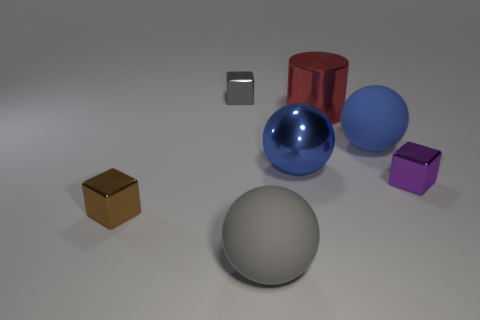The small metal object that is both left of the red shiny cylinder and in front of the cylinder is what color?
Provide a succinct answer. Brown. Are there any purple blocks left of the metallic block on the right side of the red shiny object?
Ensure brevity in your answer.  No. Are there an equal number of large blue shiny balls that are right of the big red thing and big red metal cubes?
Your answer should be very brief. Yes. There is a small purple thing in front of the metallic block that is behind the small purple metallic thing; how many blue balls are behind it?
Provide a short and direct response. 2. Is there a blue matte sphere that has the same size as the metallic cylinder?
Make the answer very short. Yes. Are there fewer spheres that are on the right side of the purple block than small red balls?
Give a very brief answer. No. What material is the big thing in front of the small metallic block in front of the block that is right of the big shiny cylinder?
Give a very brief answer. Rubber. Are there more tiny purple objects left of the purple metallic block than small purple cubes behind the brown block?
Your answer should be compact. No. How many rubber objects are either tiny cylinders or big blue objects?
Provide a short and direct response. 1. What shape is the matte thing that is the same color as the big metal sphere?
Make the answer very short. Sphere. 